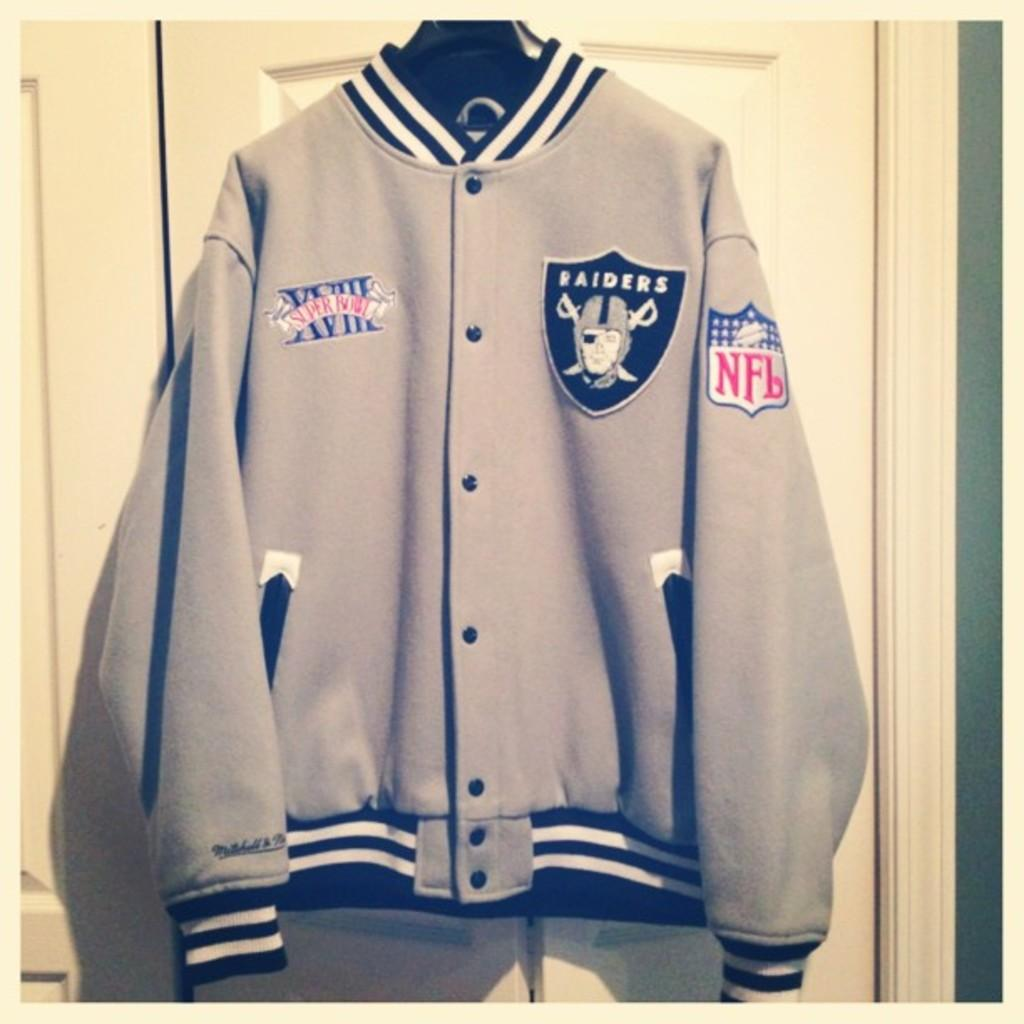What is present in the image related to clothing? There is a jacket in the image. How is the jacket positioned in the image? The jacket is hanging on a hanger. Where is the hanger located in the image? The hanger is on a door. What type of cave is visible in the image? There is no cave present in the image; it features a jacket hanging on a hanger on a door. 